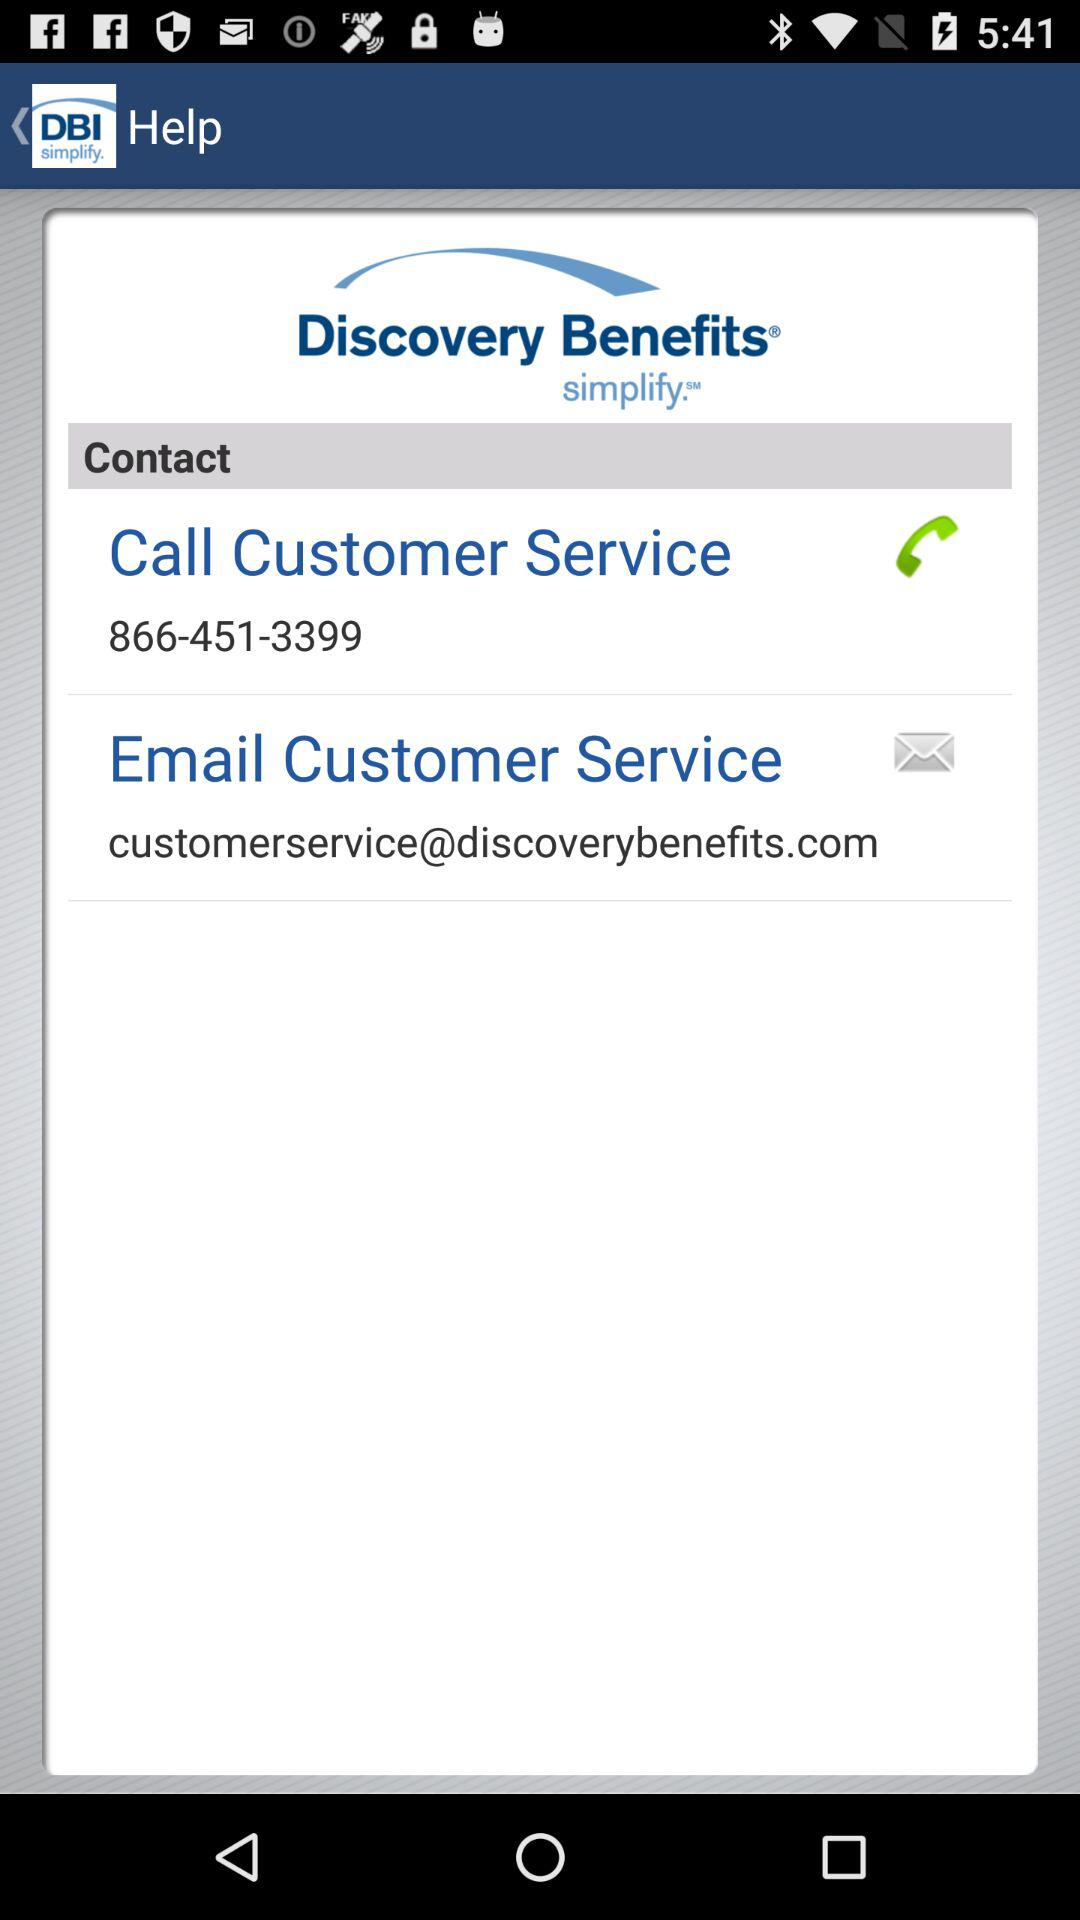How many contact options are there?
Answer the question using a single word or phrase. 2 